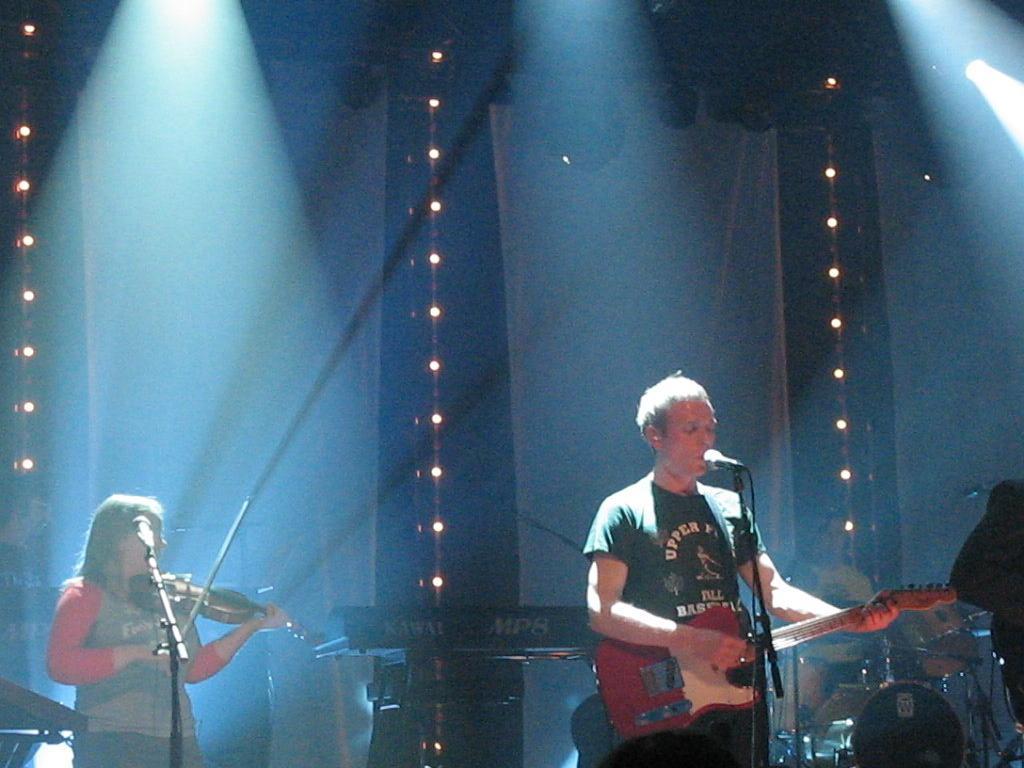Can you describe this image briefly? This is picture of a musical concert. In the left side a lady ,she is playing violin. in front of her there is a mic. On the left side a man ,he is singing along with playing guitar. In front him there is mic. In the background a man is playing drums and a keyboard is placed. On the top there is light. On the background there is curtain and light string. 